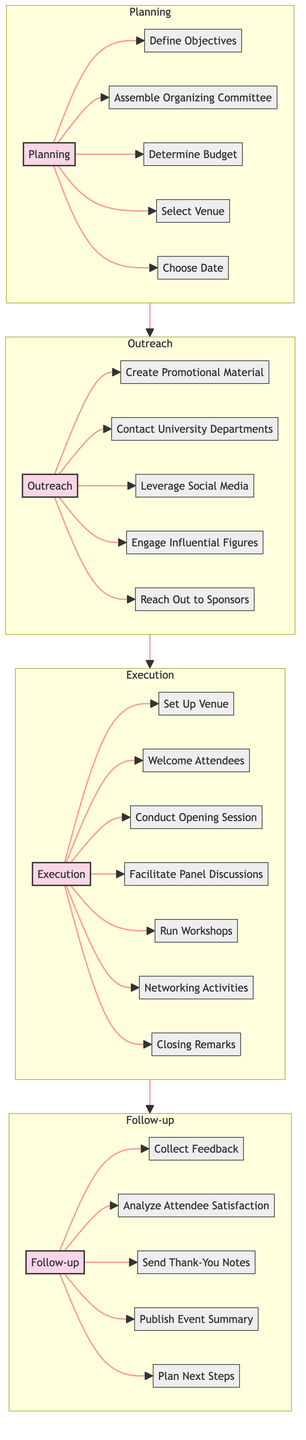What is the first stage in the flow chart? The diagram lists four stages: Planning, Outreach, Execution, and Follow-up. The first one mentioned in the diagram is Planning.
Answer: Planning How many elements are in the Execution stage? The Execution stage contains seven elements, which are listed individually in the diagram. They are Set Up Venue, Welcome Attendees, Conduct Opening Session, Facilitate Panel Discussions, Run Workshops, Networking Activities, and Closing Remarks.
Answer: Seven What follows Outreach in the flow chart? The flow chart shows a linear progression from one stage to another. After Outreach, the next stage is Execution.
Answer: Execution Which action is mentioned in the Follow-up stage? One of the elements in the Follow-up stage is Collect Feedback, which is explicitly listed in the diagram.
Answer: Collect Feedback What connects the Planning and Outreach stages? The diagram uses a directional link to represent the relationship; thus, the link connecting Planning and Outreach signifies that Outreach follows Planning.
Answer: A link What two elements does the Outreach stage start with? The first two elements in the Outreach stage are Create Promotional Material and Contact University Departments, which are outlined in the diagram under that stage.
Answer: Create Promotional Material, Contact University Departments Which stage includes "Choose Date"? The "Choose Date" element is found in the Planning stage of the diagram, indicating that it is part of the initial steps taken to organize the workshop.
Answer: Planning How many total stages are there in the flow chart? The flow chart depicts four total stages, which are Planning, Outreach, Execution, and Follow-up. Counting them gives the total number of stages.
Answer: Four What is the last element in the Follow-up stage? The last element listed in the Follow-up stage is Plan Next Steps, which comes after collecting feedback and analyzing satisfaction, among others.
Answer: Plan Next Steps 